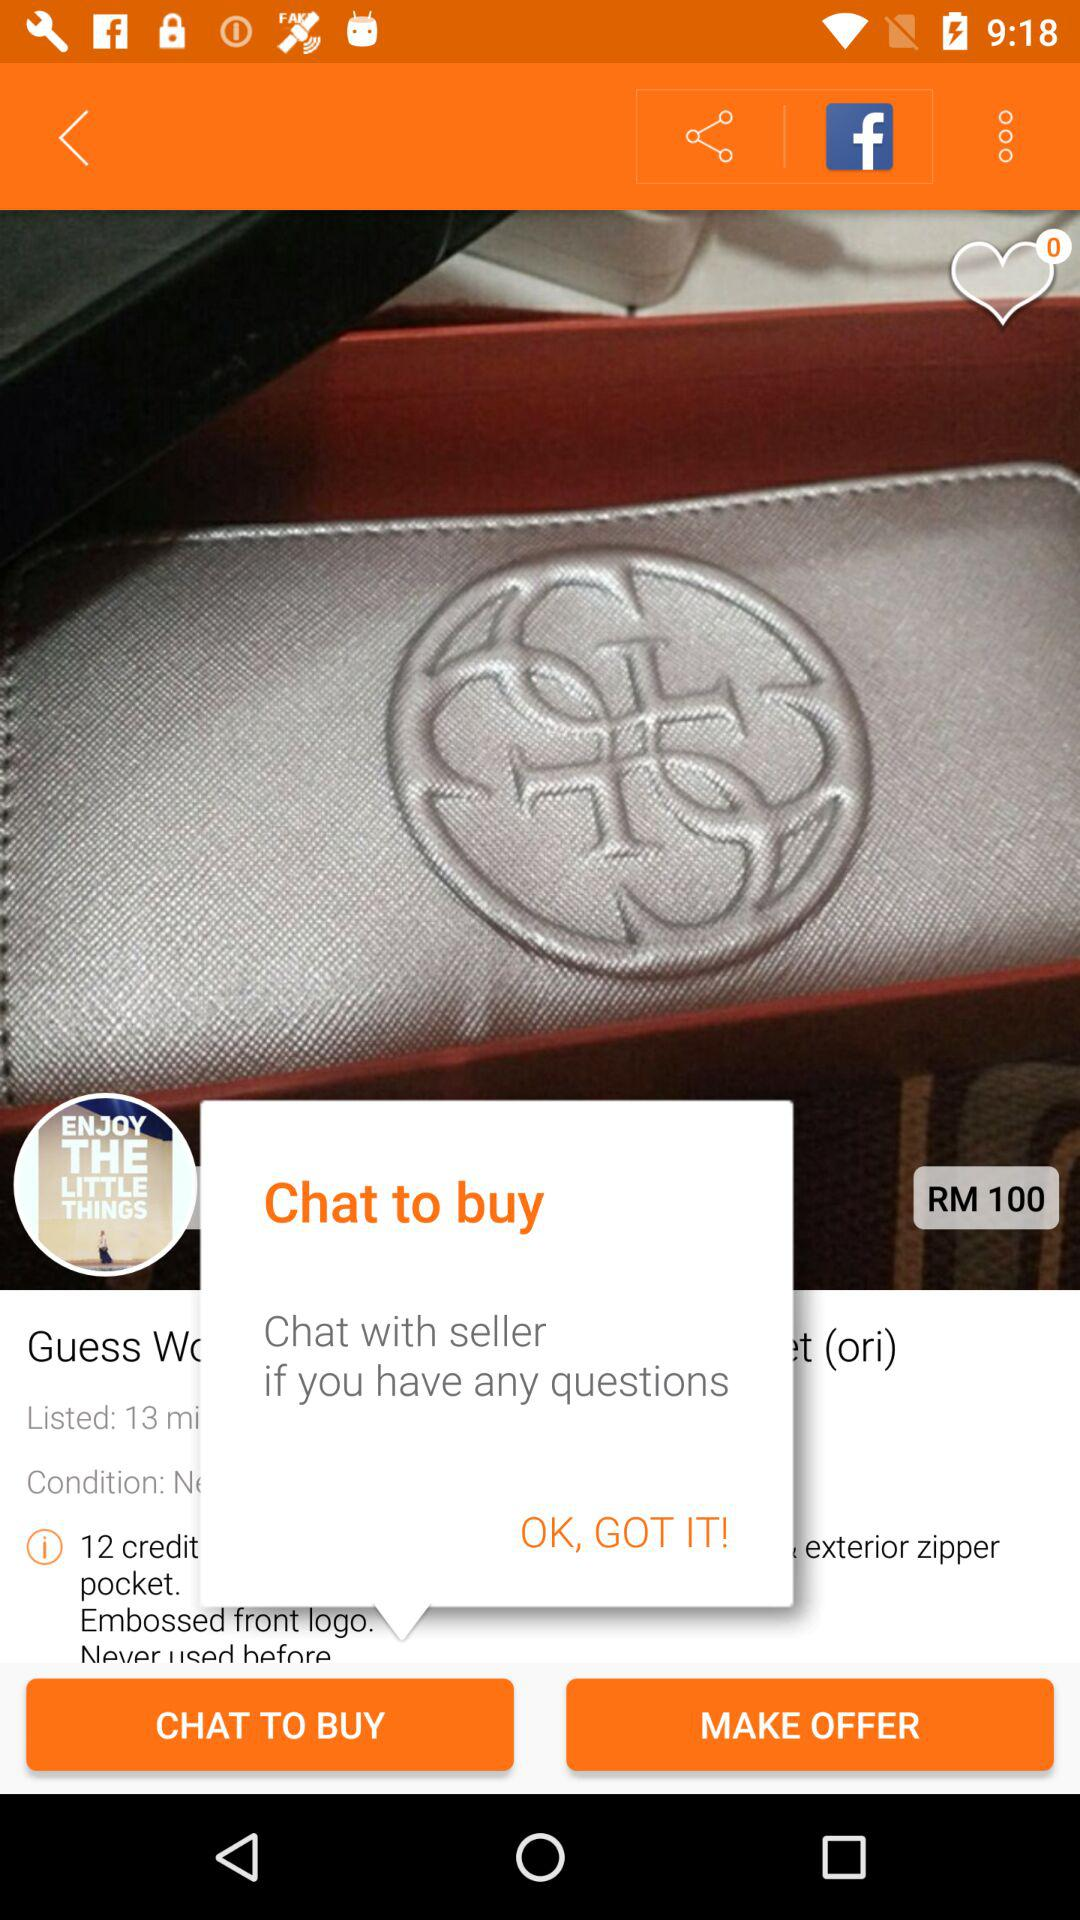How many credit pockets does the wallet have?
Answer the question using a single word or phrase. 12 